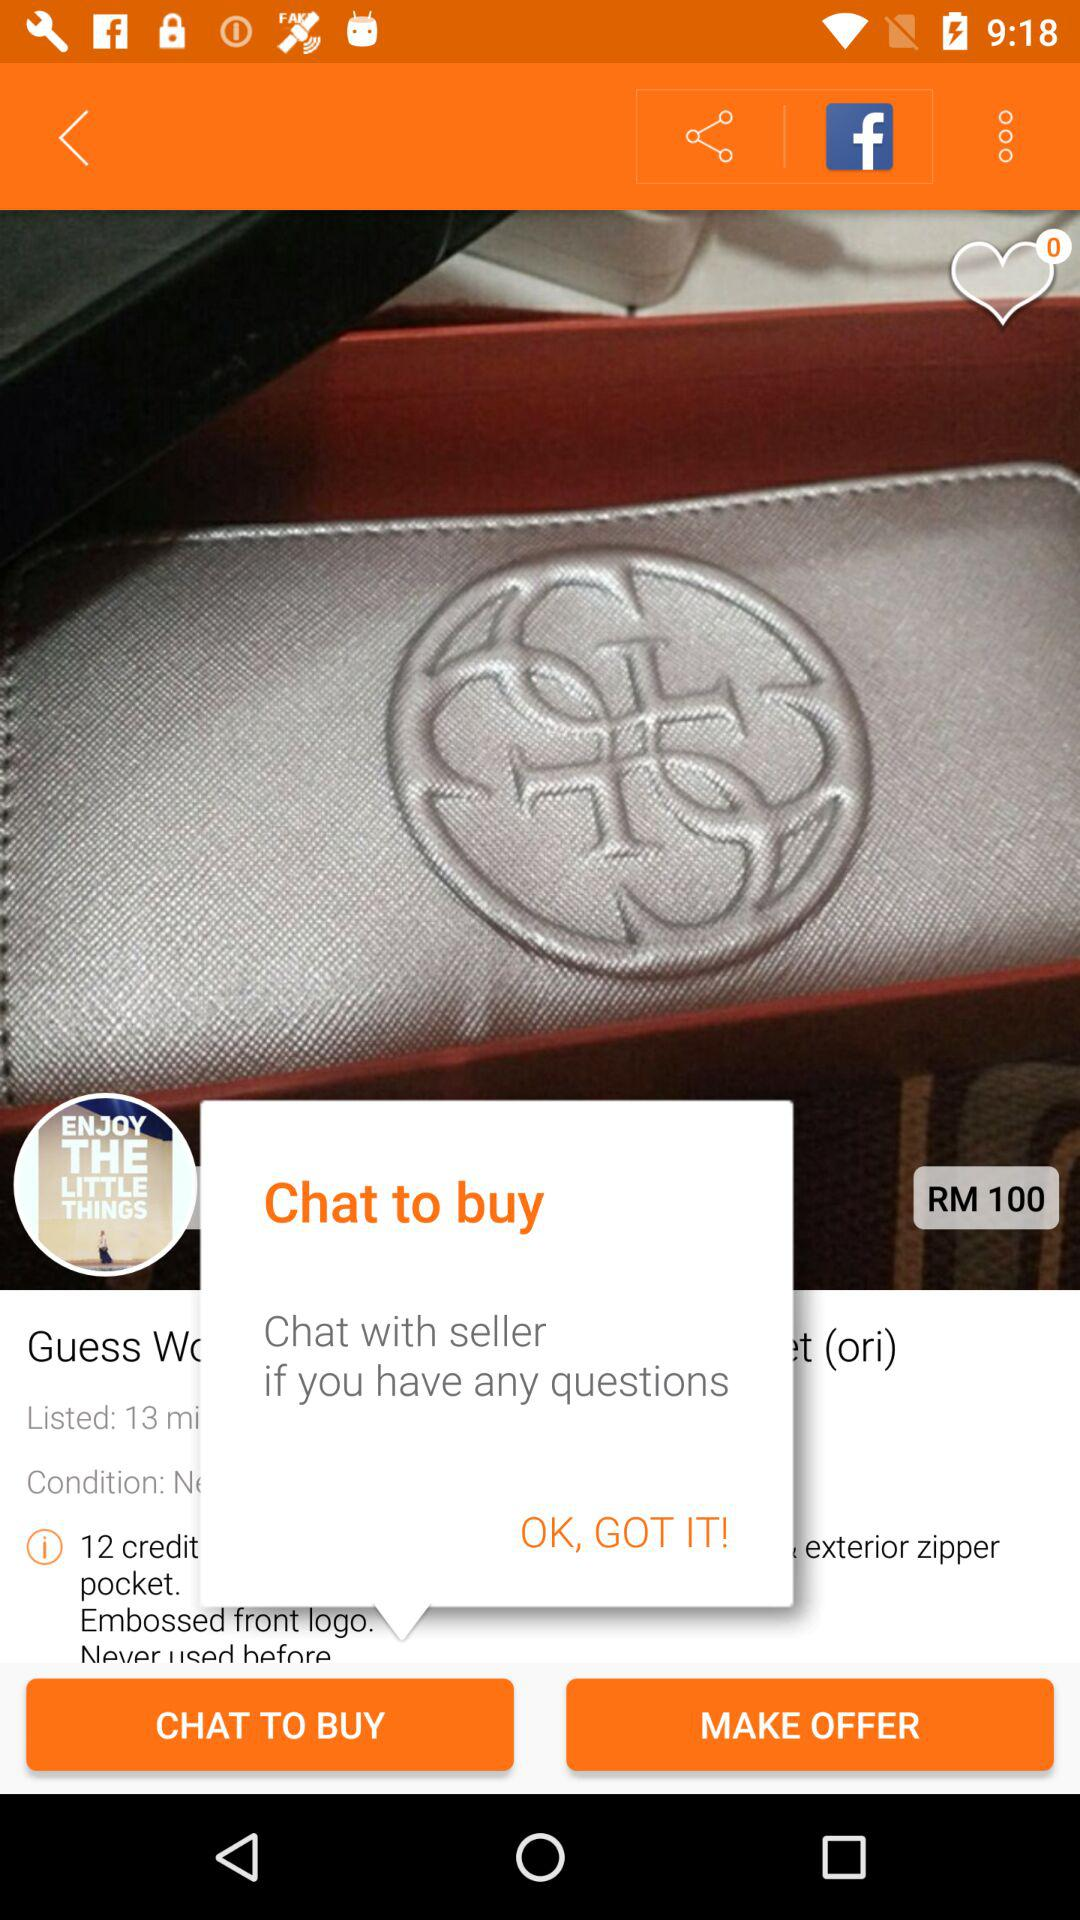How many credit pockets does the wallet have?
Answer the question using a single word or phrase. 12 